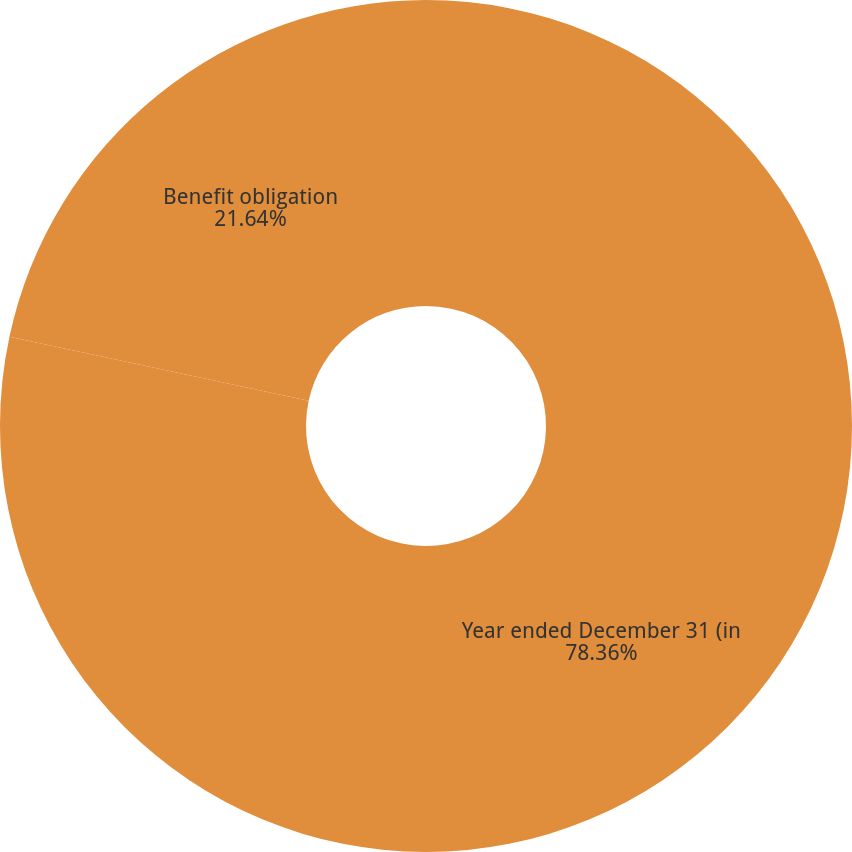Convert chart to OTSL. <chart><loc_0><loc_0><loc_500><loc_500><pie_chart><fcel>Year ended December 31 (in<fcel>Benefit obligation<nl><fcel>78.36%<fcel>21.64%<nl></chart> 